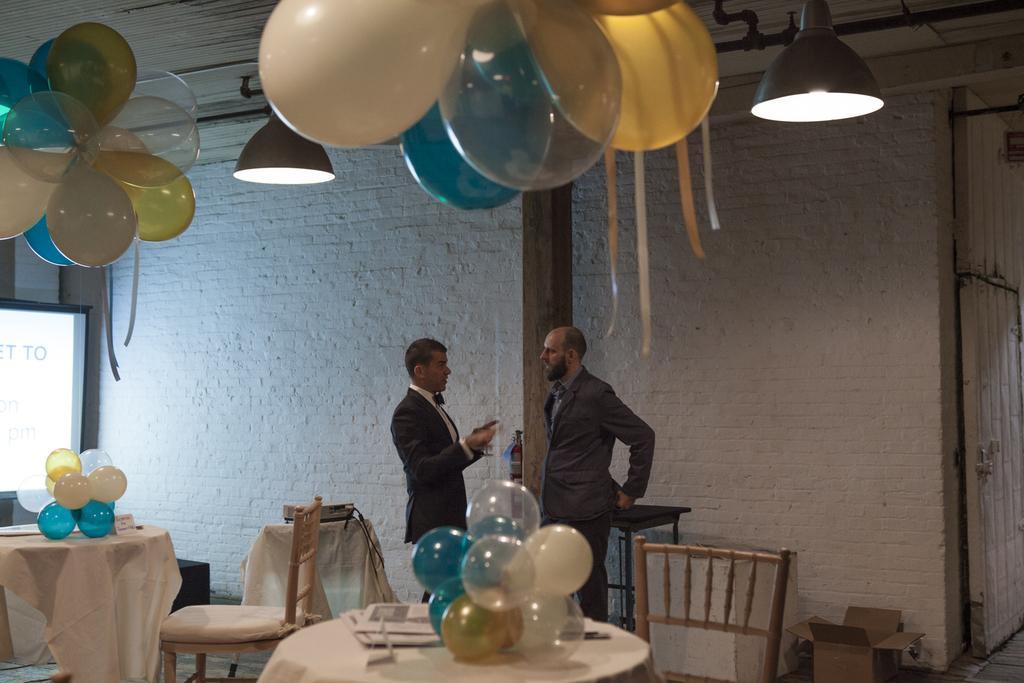Can you describe this image briefly? In the image we can see there are two people who are standing and on table there are balloons. 